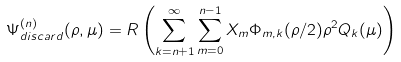Convert formula to latex. <formula><loc_0><loc_0><loc_500><loc_500>\Psi _ { d i s c a r d } ^ { ( n ) } ( \rho , \mu ) = R \left ( \sum _ { k = n + 1 } ^ { \infty } \sum _ { m = 0 } ^ { n - 1 } X _ { m } \Phi _ { m , k } ( \rho / 2 ) \rho ^ { 2 } Q _ { k } ( \mu ) \right )</formula> 